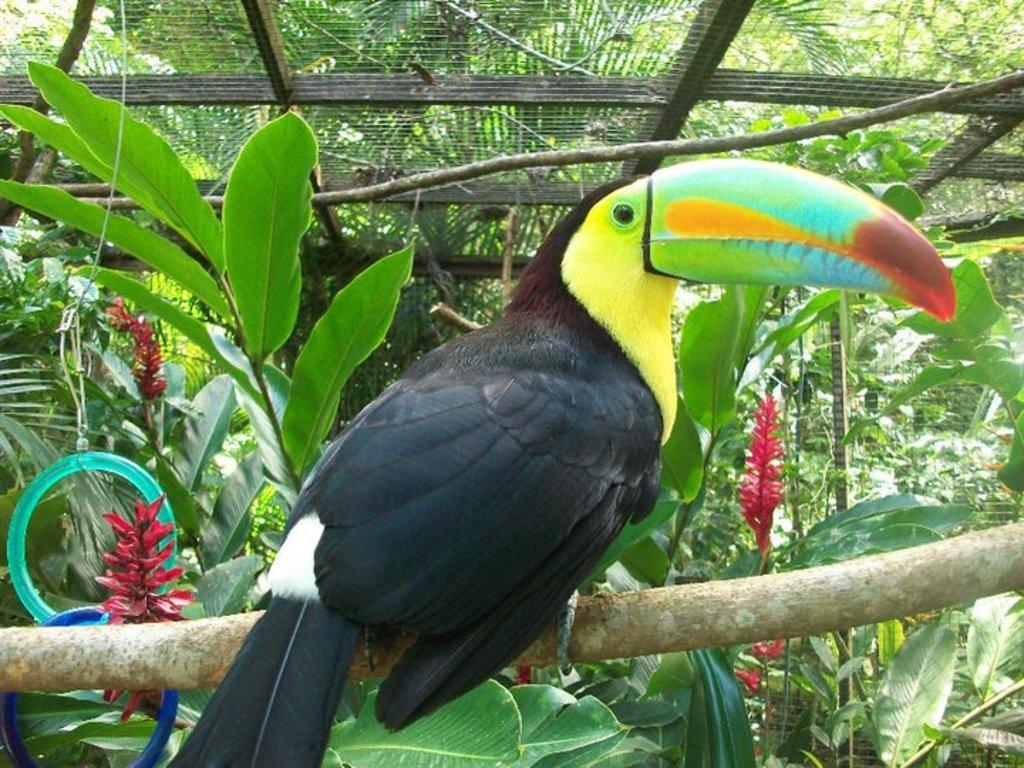What type of animal can be seen in the image? There is a bird in the image. Where is the bird located? The bird is sitting on a branch. What can be seen in the background of the image? There are many beautiful plants around the bird. What is above the bird in the image? There is a roof made up of a mesh above the bird. What type of game is the bird playing in the image? There is no game being played in the image; the bird is simply sitting on a branch. Can you see a bottle in the image? There is no bottle present in the image. 